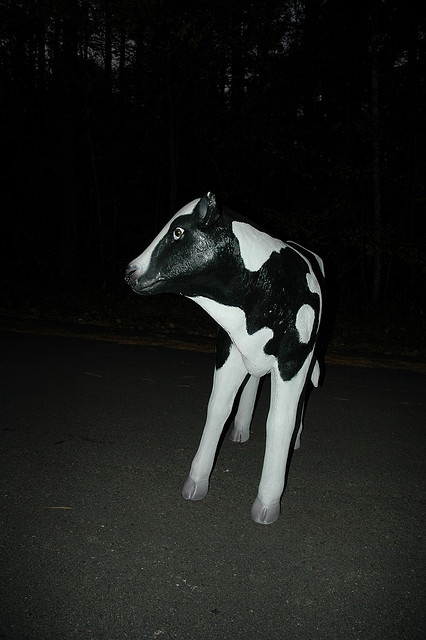Describe the objects in this image and their specific colors. I can see a cow in black, darkgray, lightgray, and gray tones in this image. 